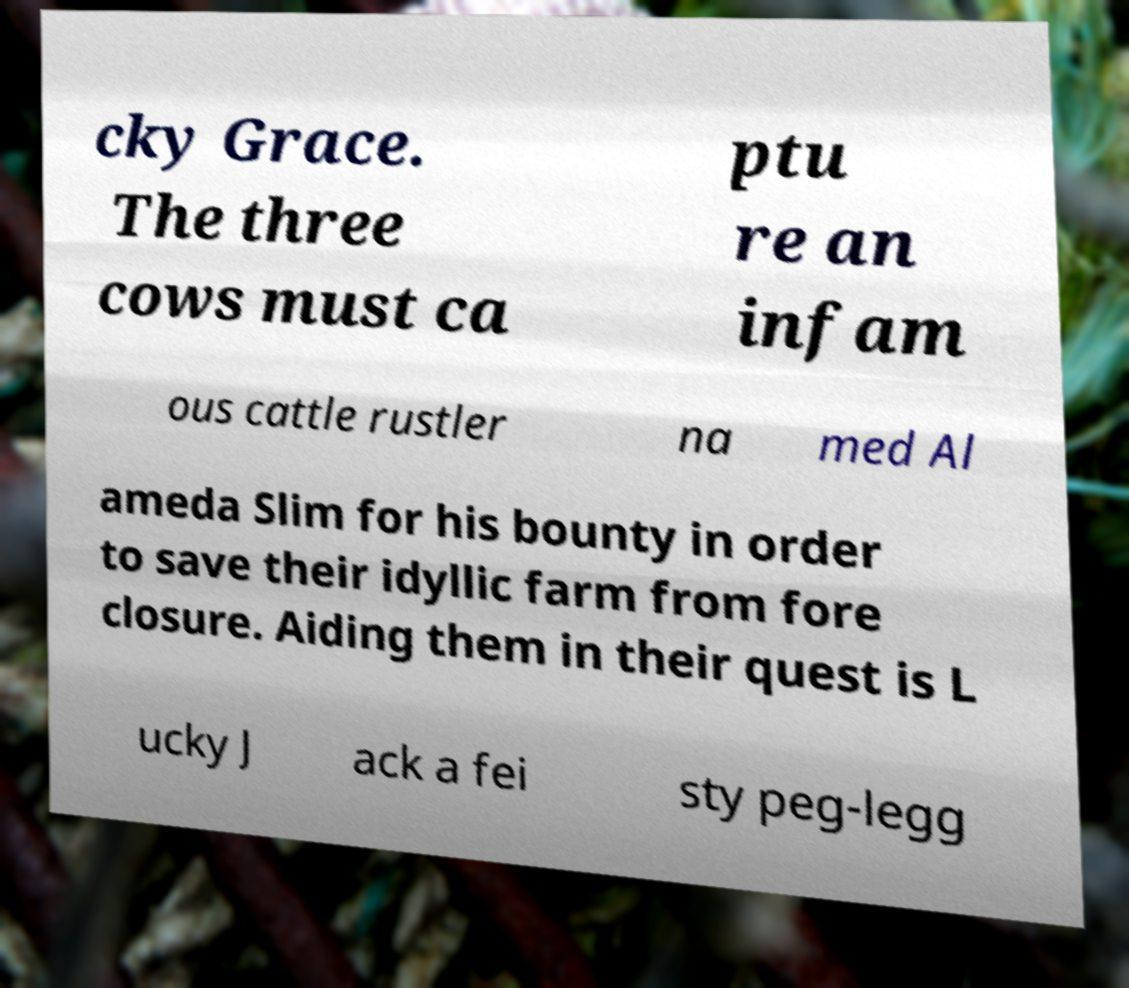Please read and relay the text visible in this image. What does it say? cky Grace. The three cows must ca ptu re an infam ous cattle rustler na med Al ameda Slim for his bounty in order to save their idyllic farm from fore closure. Aiding them in their quest is L ucky J ack a fei sty peg-legg 